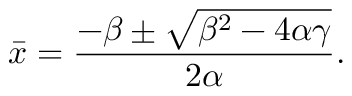<formula> <loc_0><loc_0><loc_500><loc_500>\bar { x } = \frac { - \beta \pm \sqrt { \beta ^ { 2 } - 4 \alpha \gamma } } { 2 \alpha } .</formula> 